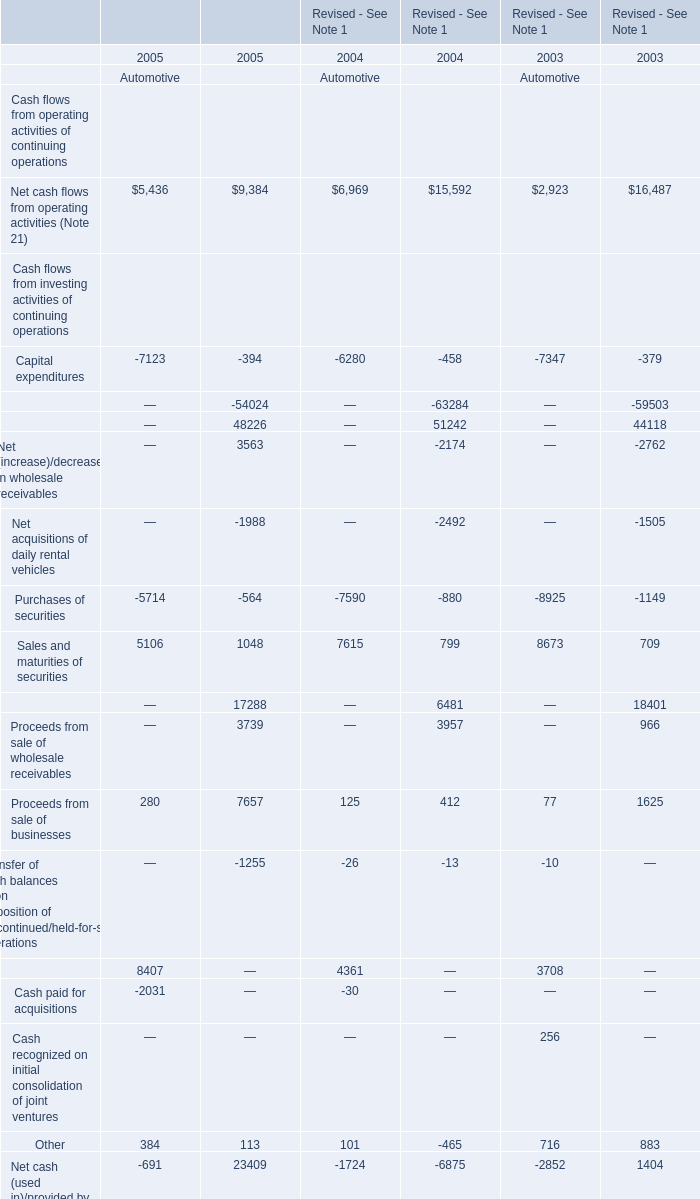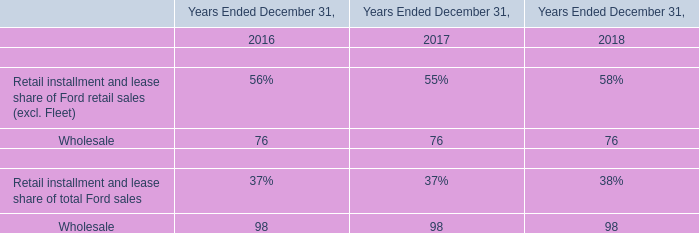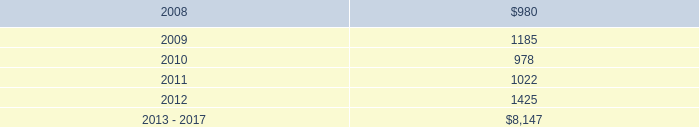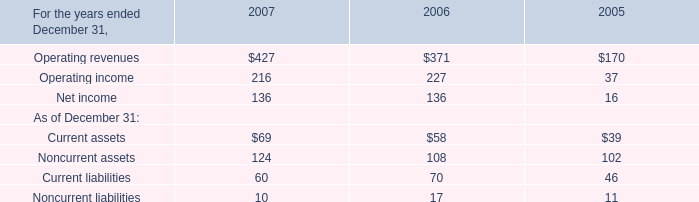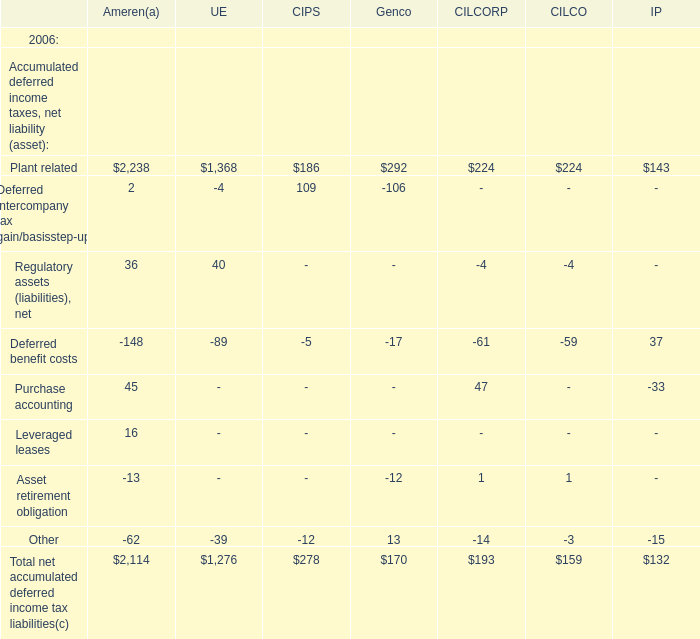What is the ratio of Plant related of CILCO in Table 1 to the Operating income in Table 0 in 2006? 
Computations: (224 / 227)
Answer: 0.98678. 